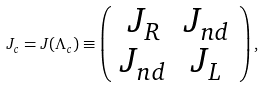<formula> <loc_0><loc_0><loc_500><loc_500>J _ { c } = J ( \Lambda _ { c } ) \equiv \left ( \begin{array} { c c } J _ { R } & J _ { n d } \\ J _ { n d } & J _ { L } \end{array} \right ) ,</formula> 